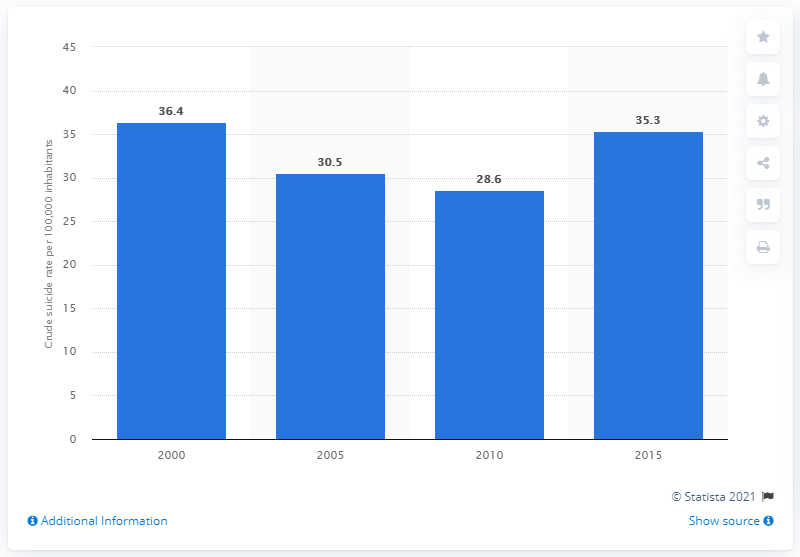Draw attention to some important aspects in this diagram. In 2015, the crude suicide rate in Sri Lanka was 35.3 per 100,000 population. 